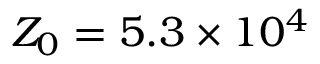Convert formula to latex. <formula><loc_0><loc_0><loc_500><loc_500>Z _ { 0 } = 5 . 3 \times 1 0 ^ { 4 }</formula> 